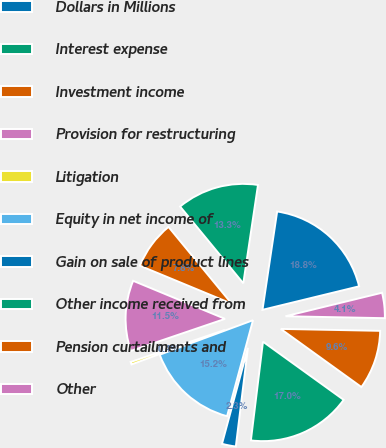Convert chart. <chart><loc_0><loc_0><loc_500><loc_500><pie_chart><fcel>Dollars in Millions<fcel>Interest expense<fcel>Investment income<fcel>Provision for restructuring<fcel>Litigation<fcel>Equity in net income of<fcel>Gain on sale of product lines<fcel>Other income received from<fcel>Pension curtailments and<fcel>Other<nl><fcel>18.84%<fcel>13.32%<fcel>7.79%<fcel>11.47%<fcel>0.42%<fcel>15.16%<fcel>2.26%<fcel>17.0%<fcel>9.63%<fcel>4.11%<nl></chart> 